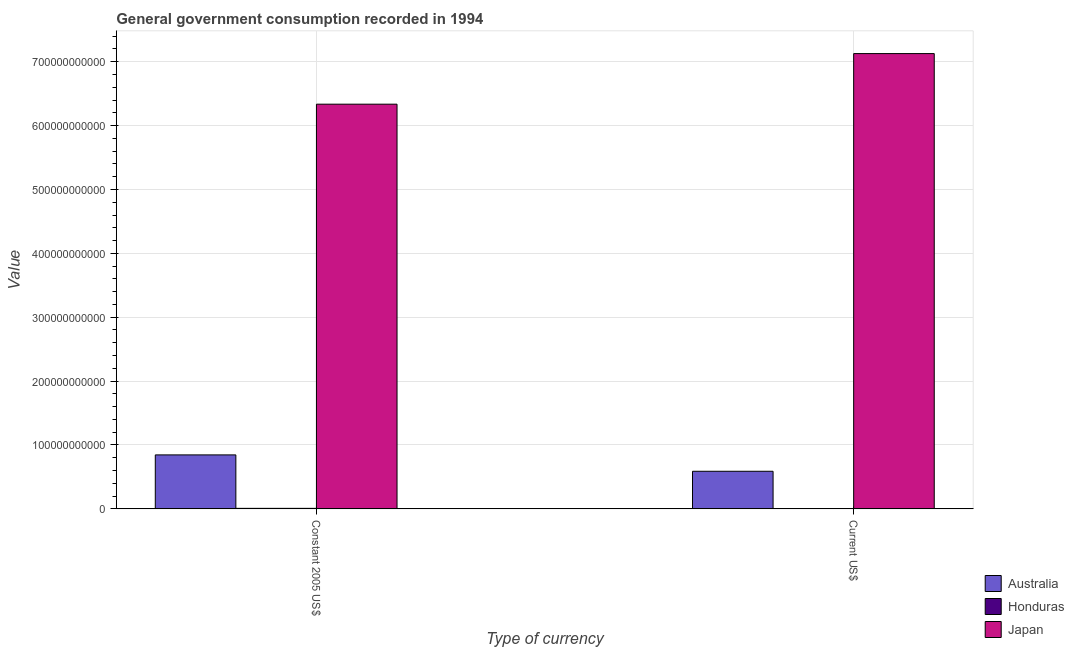How many different coloured bars are there?
Ensure brevity in your answer.  3. Are the number of bars on each tick of the X-axis equal?
Your answer should be compact. Yes. How many bars are there on the 2nd tick from the right?
Ensure brevity in your answer.  3. What is the label of the 1st group of bars from the left?
Give a very brief answer. Constant 2005 US$. What is the value consumed in current us$ in Japan?
Your response must be concise. 7.13e+11. Across all countries, what is the maximum value consumed in current us$?
Your response must be concise. 7.13e+11. Across all countries, what is the minimum value consumed in current us$?
Your answer should be very brief. 3.31e+08. In which country was the value consumed in current us$ minimum?
Your response must be concise. Honduras. What is the total value consumed in constant 2005 us$ in the graph?
Provide a succinct answer. 7.19e+11. What is the difference between the value consumed in current us$ in Honduras and that in Australia?
Your answer should be very brief. -5.85e+1. What is the difference between the value consumed in constant 2005 us$ in Australia and the value consumed in current us$ in Honduras?
Your answer should be compact. 8.41e+1. What is the average value consumed in constant 2005 us$ per country?
Offer a terse response. 2.40e+11. What is the difference between the value consumed in constant 2005 us$ and value consumed in current us$ in Australia?
Ensure brevity in your answer.  2.56e+1. In how many countries, is the value consumed in current us$ greater than 620000000000 ?
Give a very brief answer. 1. What is the ratio of the value consumed in current us$ in Australia to that in Japan?
Provide a short and direct response. 0.08. In how many countries, is the value consumed in constant 2005 us$ greater than the average value consumed in constant 2005 us$ taken over all countries?
Your answer should be very brief. 1. What does the 2nd bar from the left in Constant 2005 US$ represents?
Make the answer very short. Honduras. What does the 3rd bar from the right in Current US$ represents?
Your answer should be compact. Australia. How many bars are there?
Offer a terse response. 6. Are all the bars in the graph horizontal?
Offer a very short reply. No. What is the difference between two consecutive major ticks on the Y-axis?
Ensure brevity in your answer.  1.00e+11. Are the values on the major ticks of Y-axis written in scientific E-notation?
Ensure brevity in your answer.  No. Does the graph contain grids?
Keep it short and to the point. Yes. Where does the legend appear in the graph?
Offer a terse response. Bottom right. How many legend labels are there?
Ensure brevity in your answer.  3. How are the legend labels stacked?
Provide a succinct answer. Vertical. What is the title of the graph?
Provide a short and direct response. General government consumption recorded in 1994. What is the label or title of the X-axis?
Ensure brevity in your answer.  Type of currency. What is the label or title of the Y-axis?
Offer a terse response. Value. What is the Value of Australia in Constant 2005 US$?
Your response must be concise. 8.44e+1. What is the Value in Honduras in Constant 2005 US$?
Give a very brief answer. 7.64e+08. What is the Value of Japan in Constant 2005 US$?
Give a very brief answer. 6.33e+11. What is the Value in Australia in Current US$?
Give a very brief answer. 5.88e+1. What is the Value of Honduras in Current US$?
Provide a succinct answer. 3.31e+08. What is the Value in Japan in Current US$?
Offer a terse response. 7.13e+11. Across all Type of currency, what is the maximum Value of Australia?
Make the answer very short. 8.44e+1. Across all Type of currency, what is the maximum Value of Honduras?
Your answer should be very brief. 7.64e+08. Across all Type of currency, what is the maximum Value in Japan?
Offer a very short reply. 7.13e+11. Across all Type of currency, what is the minimum Value in Australia?
Offer a terse response. 5.88e+1. Across all Type of currency, what is the minimum Value in Honduras?
Your answer should be compact. 3.31e+08. Across all Type of currency, what is the minimum Value in Japan?
Your answer should be very brief. 6.33e+11. What is the total Value of Australia in the graph?
Your answer should be compact. 1.43e+11. What is the total Value in Honduras in the graph?
Keep it short and to the point. 1.09e+09. What is the total Value in Japan in the graph?
Your answer should be very brief. 1.35e+12. What is the difference between the Value of Australia in Constant 2005 US$ and that in Current US$?
Keep it short and to the point. 2.56e+1. What is the difference between the Value of Honduras in Constant 2005 US$ and that in Current US$?
Make the answer very short. 4.34e+08. What is the difference between the Value in Japan in Constant 2005 US$ and that in Current US$?
Provide a succinct answer. -7.92e+1. What is the difference between the Value in Australia in Constant 2005 US$ and the Value in Honduras in Current US$?
Your response must be concise. 8.41e+1. What is the difference between the Value of Australia in Constant 2005 US$ and the Value of Japan in Current US$?
Offer a terse response. -6.28e+11. What is the difference between the Value in Honduras in Constant 2005 US$ and the Value in Japan in Current US$?
Give a very brief answer. -7.12e+11. What is the average Value in Australia per Type of currency?
Provide a short and direct response. 7.16e+1. What is the average Value in Honduras per Type of currency?
Ensure brevity in your answer.  5.47e+08. What is the average Value of Japan per Type of currency?
Provide a short and direct response. 6.73e+11. What is the difference between the Value of Australia and Value of Honduras in Constant 2005 US$?
Provide a short and direct response. 8.37e+1. What is the difference between the Value of Australia and Value of Japan in Constant 2005 US$?
Offer a terse response. -5.49e+11. What is the difference between the Value in Honduras and Value in Japan in Constant 2005 US$?
Your answer should be very brief. -6.33e+11. What is the difference between the Value in Australia and Value in Honduras in Current US$?
Ensure brevity in your answer.  5.85e+1. What is the difference between the Value in Australia and Value in Japan in Current US$?
Provide a short and direct response. -6.54e+11. What is the difference between the Value of Honduras and Value of Japan in Current US$?
Your answer should be very brief. -7.12e+11. What is the ratio of the Value in Australia in Constant 2005 US$ to that in Current US$?
Your response must be concise. 1.44. What is the ratio of the Value in Honduras in Constant 2005 US$ to that in Current US$?
Your answer should be compact. 2.31. What is the ratio of the Value of Japan in Constant 2005 US$ to that in Current US$?
Keep it short and to the point. 0.89. What is the difference between the highest and the second highest Value of Australia?
Your answer should be very brief. 2.56e+1. What is the difference between the highest and the second highest Value in Honduras?
Your answer should be compact. 4.34e+08. What is the difference between the highest and the second highest Value of Japan?
Keep it short and to the point. 7.92e+1. What is the difference between the highest and the lowest Value of Australia?
Make the answer very short. 2.56e+1. What is the difference between the highest and the lowest Value of Honduras?
Provide a succinct answer. 4.34e+08. What is the difference between the highest and the lowest Value in Japan?
Keep it short and to the point. 7.92e+1. 